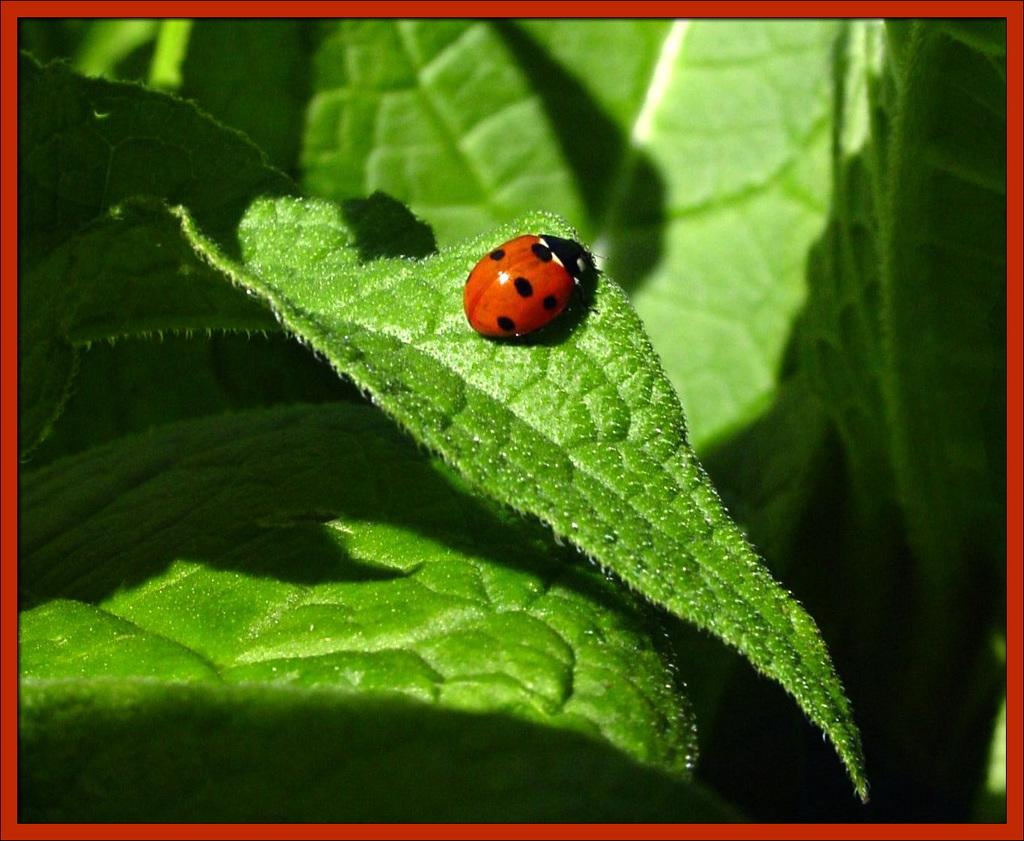What is the main subject in the foreground of the image? There is an insect in the foreground of the image. Where is the insect located? The insect is on a leaf. What can be seen around the insect? There are leaves surrounding the insect. What type of cabbage is the insect eating in the image? There is no cabbage present in the image; the insect is on a leaf. How does the alarm sound in the image? There is no alarm present in the image. 